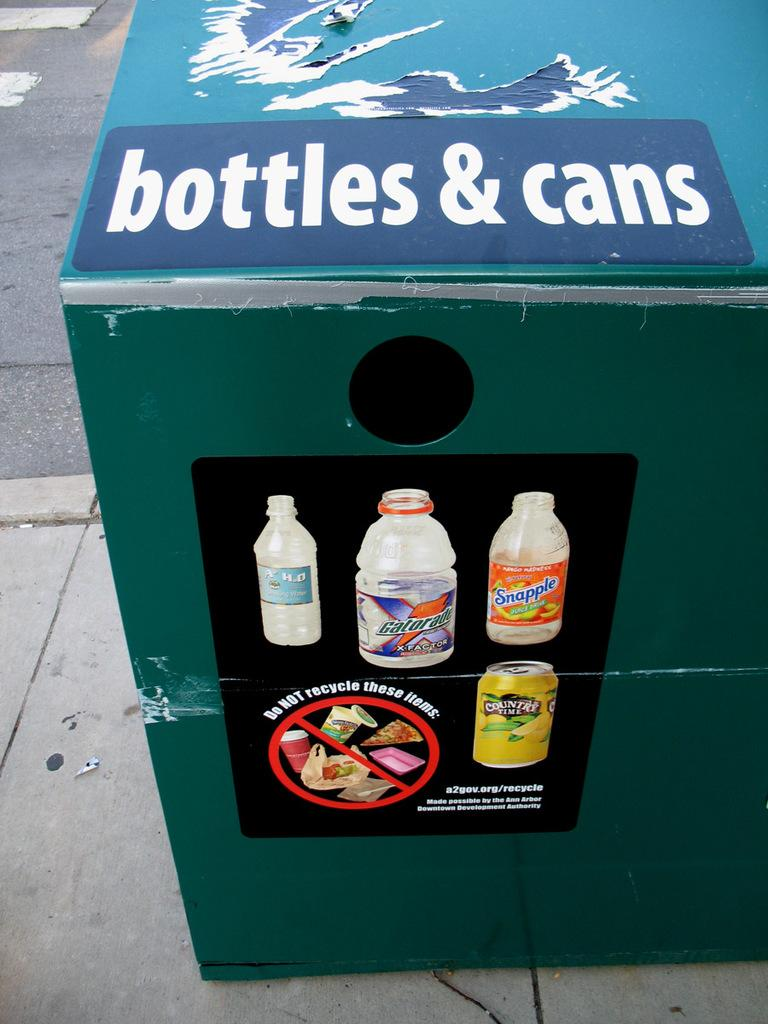<image>
Present a compact description of the photo's key features. The container asks to not recycle certain items. 